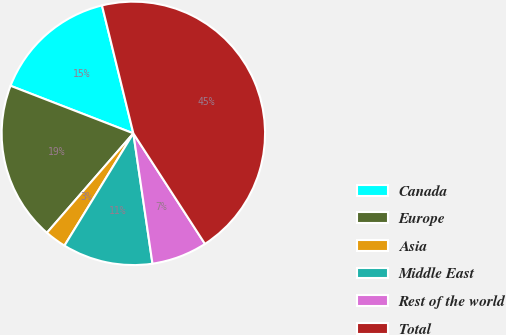Convert chart. <chart><loc_0><loc_0><loc_500><loc_500><pie_chart><fcel>Canada<fcel>Europe<fcel>Asia<fcel>Middle East<fcel>Rest of the world<fcel>Total<nl><fcel>15.29%<fcel>19.49%<fcel>2.63%<fcel>11.08%<fcel>6.83%<fcel>44.68%<nl></chart> 